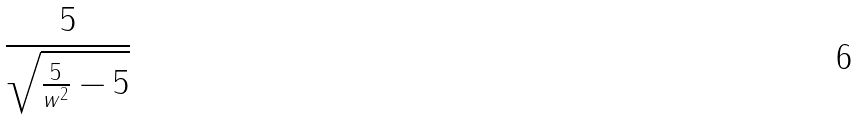<formula> <loc_0><loc_0><loc_500><loc_500>\frac { 5 } { \sqrt { \frac { 5 } { w ^ { 2 } } - 5 } }</formula> 